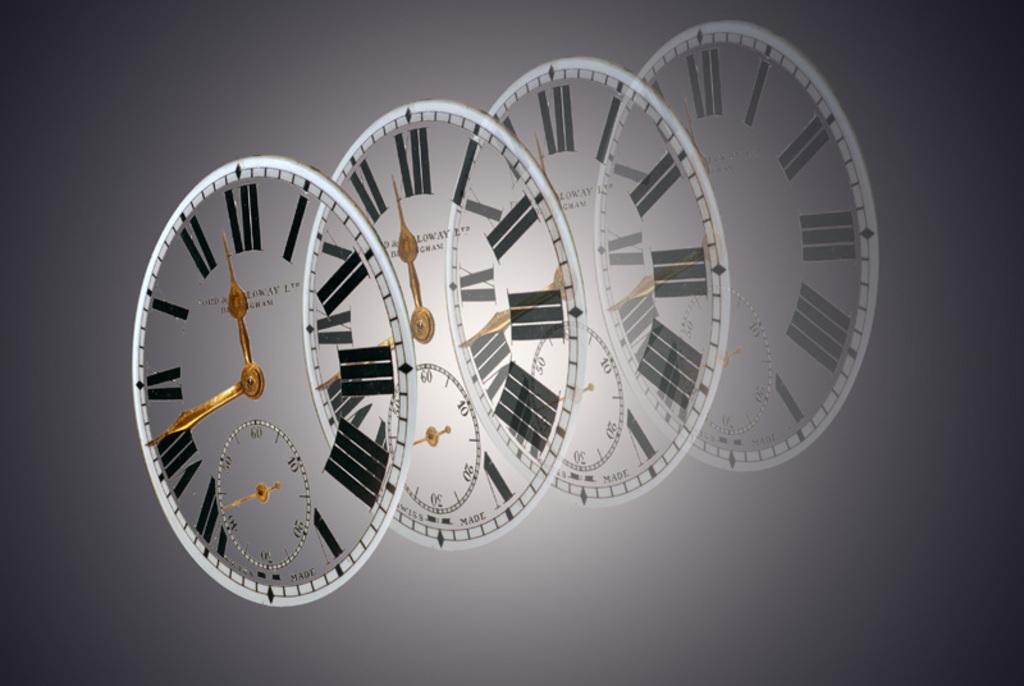What time is shown on the first clock?
Offer a terse response. 11:42. 